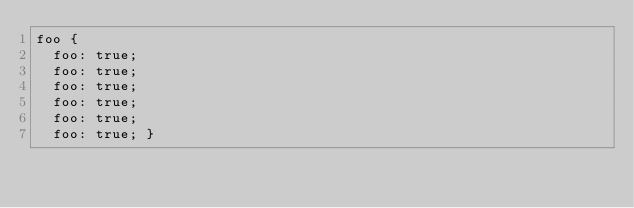Convert code to text. <code><loc_0><loc_0><loc_500><loc_500><_CSS_>foo {
  foo: true;
  foo: true;
  foo: true;
  foo: true;
  foo: true;
  foo: true; }
</code> 